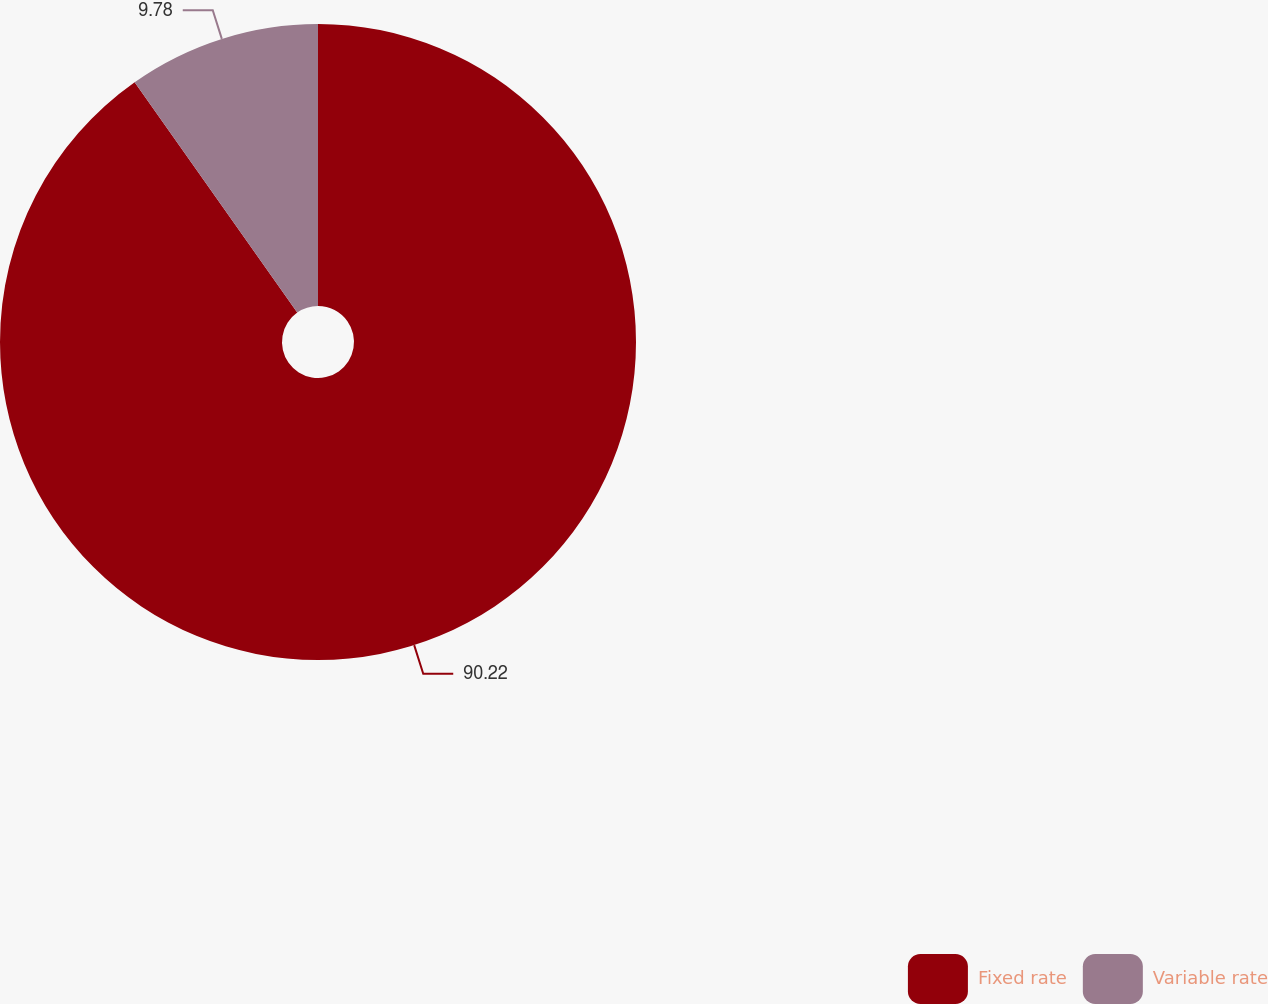<chart> <loc_0><loc_0><loc_500><loc_500><pie_chart><fcel>Fixed rate<fcel>Variable rate<nl><fcel>90.22%<fcel>9.78%<nl></chart> 